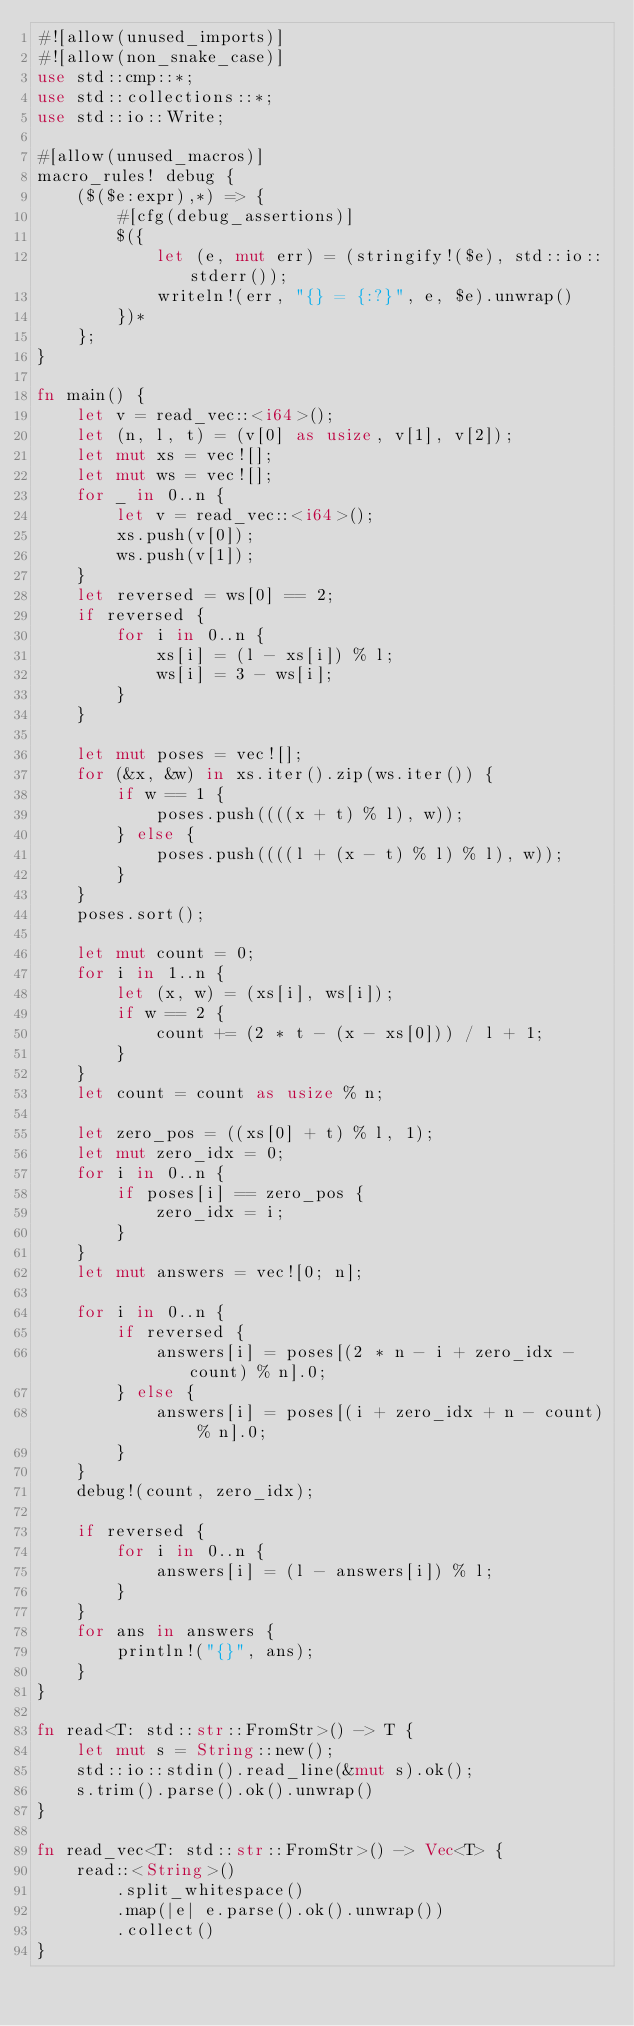Convert code to text. <code><loc_0><loc_0><loc_500><loc_500><_Rust_>#![allow(unused_imports)]
#![allow(non_snake_case)]
use std::cmp::*;
use std::collections::*;
use std::io::Write;

#[allow(unused_macros)]
macro_rules! debug {
    ($($e:expr),*) => {
        #[cfg(debug_assertions)]
        $({
            let (e, mut err) = (stringify!($e), std::io::stderr());
            writeln!(err, "{} = {:?}", e, $e).unwrap()
        })*
    };
}

fn main() {
    let v = read_vec::<i64>();
    let (n, l, t) = (v[0] as usize, v[1], v[2]);
    let mut xs = vec![];
    let mut ws = vec![];
    for _ in 0..n {
        let v = read_vec::<i64>();
        xs.push(v[0]);
        ws.push(v[1]);
    }
    let reversed = ws[0] == 2;
    if reversed {
        for i in 0..n {
            xs[i] = (l - xs[i]) % l;
            ws[i] = 3 - ws[i];
        }
    }

    let mut poses = vec![];
    for (&x, &w) in xs.iter().zip(ws.iter()) {
        if w == 1 {
            poses.push((((x + t) % l), w));
        } else {
            poses.push((((l + (x - t) % l) % l), w));
        }
    }
    poses.sort();

    let mut count = 0;
    for i in 1..n {
        let (x, w) = (xs[i], ws[i]);
        if w == 2 {
            count += (2 * t - (x - xs[0])) / l + 1;
        }
    }
    let count = count as usize % n;

    let zero_pos = ((xs[0] + t) % l, 1);
    let mut zero_idx = 0;
    for i in 0..n {
        if poses[i] == zero_pos {
            zero_idx = i;
        }
    }
    let mut answers = vec![0; n];

    for i in 0..n {
        if reversed {
            answers[i] = poses[(2 * n - i + zero_idx - count) % n].0;
        } else {
            answers[i] = poses[(i + zero_idx + n - count) % n].0;
        }
    }
    debug!(count, zero_idx);

    if reversed {
        for i in 0..n {
            answers[i] = (l - answers[i]) % l;
        }
    }
    for ans in answers {
        println!("{}", ans);
    }
}

fn read<T: std::str::FromStr>() -> T {
    let mut s = String::new();
    std::io::stdin().read_line(&mut s).ok();
    s.trim().parse().ok().unwrap()
}

fn read_vec<T: std::str::FromStr>() -> Vec<T> {
    read::<String>()
        .split_whitespace()
        .map(|e| e.parse().ok().unwrap())
        .collect()
}
</code> 